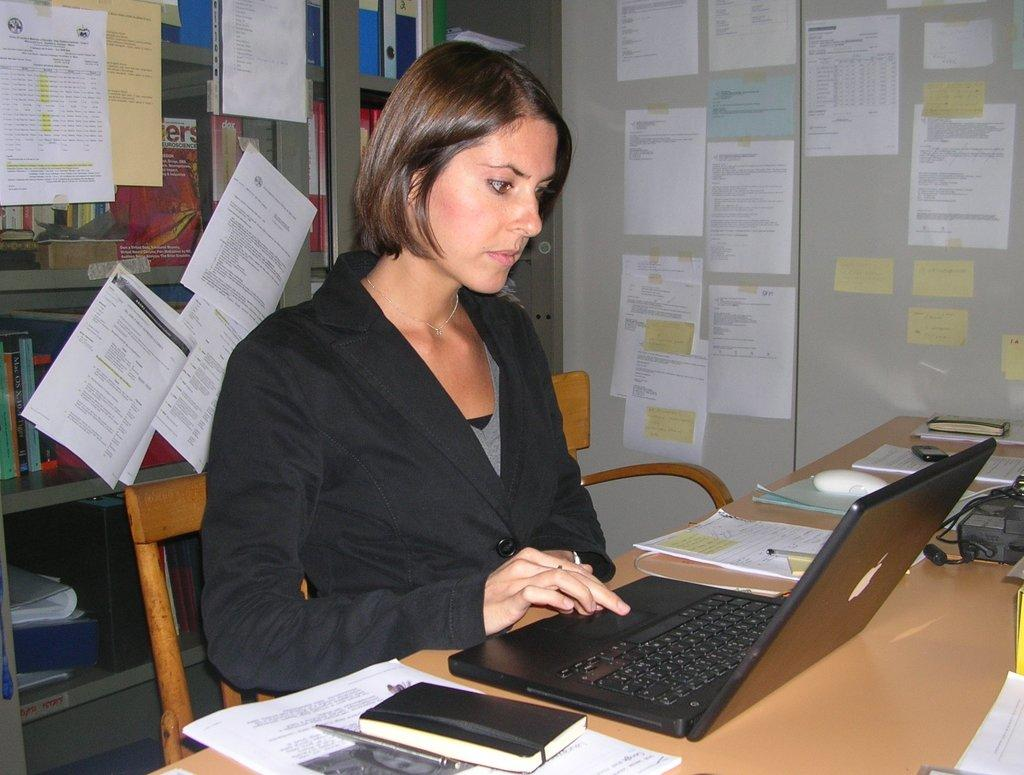<image>
Present a compact description of the photo's key features. A woman sits at a desk with a journal with the letters "ers" visible behind her. 